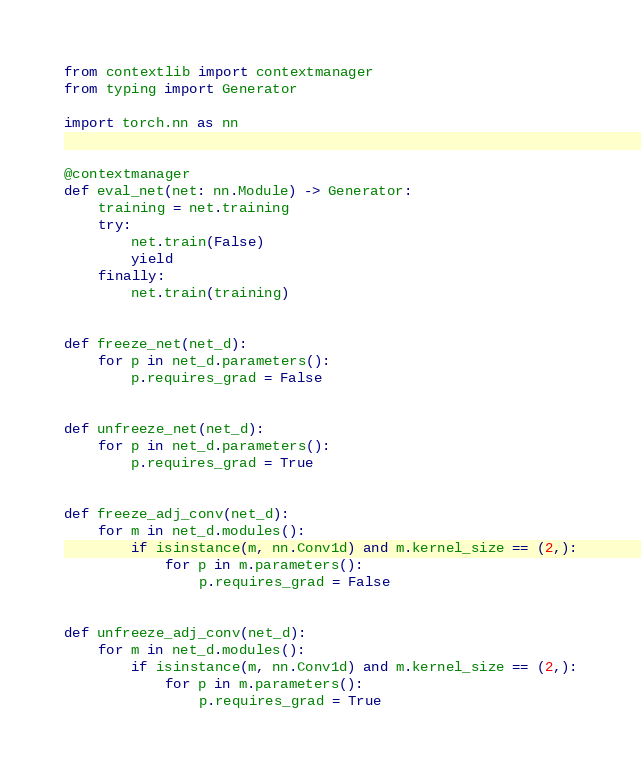<code> <loc_0><loc_0><loc_500><loc_500><_Python_>from contextlib import contextmanager
from typing import Generator

import torch.nn as nn


@contextmanager
def eval_net(net: nn.Module) -> Generator:
    training = net.training
    try:
        net.train(False)
        yield
    finally:
        net.train(training)


def freeze_net(net_d):
    for p in net_d.parameters():
        p.requires_grad = False


def unfreeze_net(net_d):
    for p in net_d.parameters():
        p.requires_grad = True


def freeze_adj_conv(net_d):
    for m in net_d.modules():
        if isinstance(m, nn.Conv1d) and m.kernel_size == (2,):
            for p in m.parameters():
                p.requires_grad = False


def unfreeze_adj_conv(net_d):
    for m in net_d.modules():
        if isinstance(m, nn.Conv1d) and m.kernel_size == (2,):
            for p in m.parameters():
                p.requires_grad = True
</code> 